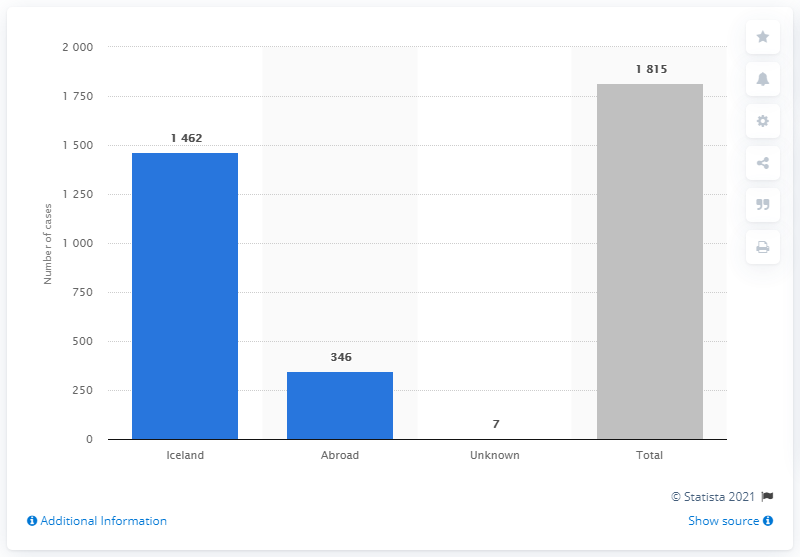Draw attention to some important aspects in this diagram. According to reported cases, a total of 346 individuals in Iceland have been confirmed to have contracted COVID-19, with a significant number having been infected abroad. 